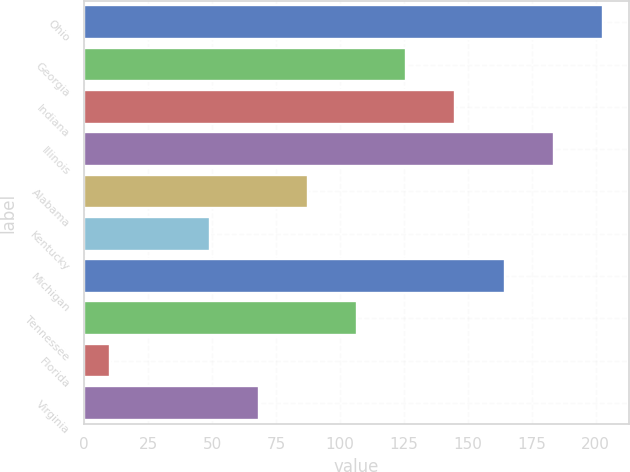Convert chart to OTSL. <chart><loc_0><loc_0><loc_500><loc_500><bar_chart><fcel>Ohio<fcel>Georgia<fcel>Indiana<fcel>Illinois<fcel>Alabama<fcel>Kentucky<fcel>Michigan<fcel>Tennessee<fcel>Florida<fcel>Virginia<nl><fcel>202.8<fcel>126<fcel>145.2<fcel>183.6<fcel>87.6<fcel>49.2<fcel>164.4<fcel>106.8<fcel>10<fcel>68.4<nl></chart> 